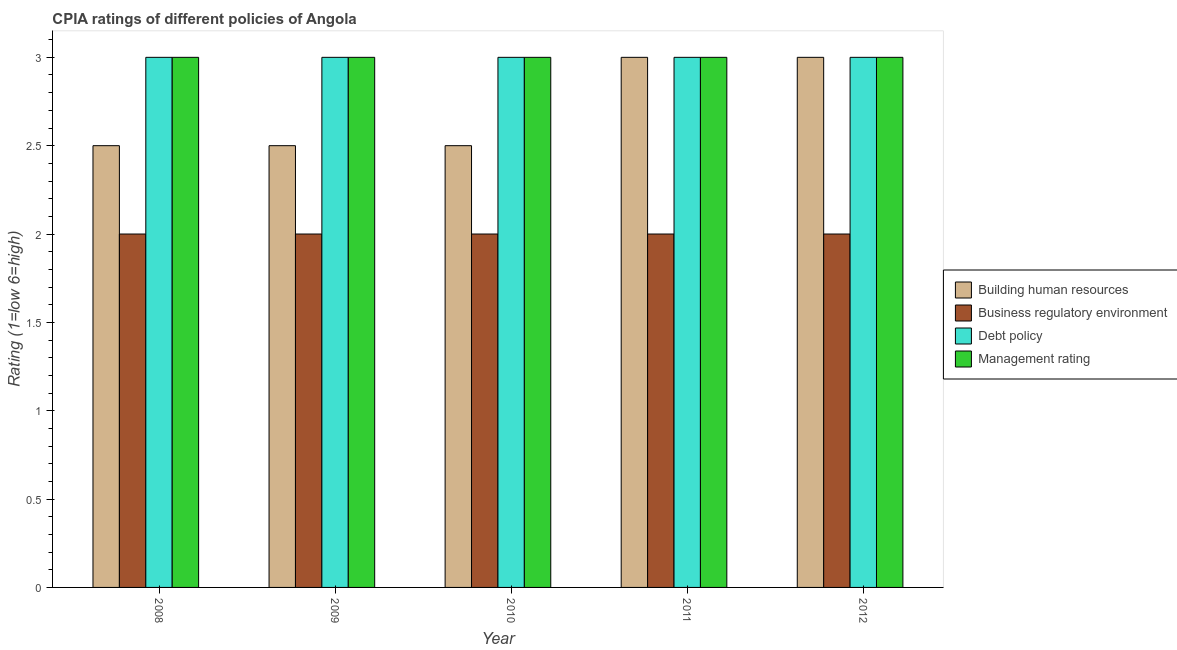How many bars are there on the 1st tick from the right?
Give a very brief answer. 4. What is the label of the 1st group of bars from the left?
Ensure brevity in your answer.  2008. In how many cases, is the number of bars for a given year not equal to the number of legend labels?
Provide a succinct answer. 0. Across all years, what is the maximum cpia rating of business regulatory environment?
Keep it short and to the point. 2. Across all years, what is the minimum cpia rating of debt policy?
Offer a terse response. 3. In which year was the cpia rating of management maximum?
Ensure brevity in your answer.  2008. In how many years, is the cpia rating of business regulatory environment greater than 0.30000000000000004?
Your answer should be very brief. 5. Is the difference between the cpia rating of management in 2008 and 2009 greater than the difference between the cpia rating of debt policy in 2008 and 2009?
Keep it short and to the point. No. What is the difference between the highest and the lowest cpia rating of debt policy?
Give a very brief answer. 0. Is it the case that in every year, the sum of the cpia rating of building human resources and cpia rating of debt policy is greater than the sum of cpia rating of management and cpia rating of business regulatory environment?
Give a very brief answer. No. What does the 3rd bar from the left in 2011 represents?
Your response must be concise. Debt policy. What does the 4th bar from the right in 2012 represents?
Offer a very short reply. Building human resources. Is it the case that in every year, the sum of the cpia rating of building human resources and cpia rating of business regulatory environment is greater than the cpia rating of debt policy?
Ensure brevity in your answer.  Yes. How many bars are there?
Your answer should be very brief. 20. Are all the bars in the graph horizontal?
Your answer should be very brief. No. What is the difference between two consecutive major ticks on the Y-axis?
Ensure brevity in your answer.  0.5. Are the values on the major ticks of Y-axis written in scientific E-notation?
Provide a short and direct response. No. Where does the legend appear in the graph?
Your response must be concise. Center right. How many legend labels are there?
Give a very brief answer. 4. What is the title of the graph?
Your answer should be compact. CPIA ratings of different policies of Angola. Does "Custom duties" appear as one of the legend labels in the graph?
Your answer should be compact. No. What is the label or title of the Y-axis?
Provide a short and direct response. Rating (1=low 6=high). What is the Rating (1=low 6=high) in Building human resources in 2008?
Offer a terse response. 2.5. What is the Rating (1=low 6=high) in Debt policy in 2008?
Offer a terse response. 3. What is the Rating (1=low 6=high) of Management rating in 2008?
Your answer should be compact. 3. What is the Rating (1=low 6=high) of Business regulatory environment in 2009?
Keep it short and to the point. 2. What is the Rating (1=low 6=high) in Management rating in 2009?
Offer a terse response. 3. What is the Rating (1=low 6=high) of Building human resources in 2010?
Your answer should be compact. 2.5. What is the Rating (1=low 6=high) in Debt policy in 2010?
Offer a very short reply. 3. What is the Rating (1=low 6=high) in Management rating in 2010?
Provide a succinct answer. 3. What is the Rating (1=low 6=high) of Management rating in 2011?
Your answer should be compact. 3. What is the Rating (1=low 6=high) in Building human resources in 2012?
Make the answer very short. 3. What is the Rating (1=low 6=high) in Management rating in 2012?
Ensure brevity in your answer.  3. Across all years, what is the maximum Rating (1=low 6=high) of Debt policy?
Provide a short and direct response. 3. Across all years, what is the maximum Rating (1=low 6=high) in Management rating?
Offer a terse response. 3. Across all years, what is the minimum Rating (1=low 6=high) of Debt policy?
Provide a short and direct response. 3. What is the difference between the Rating (1=low 6=high) of Business regulatory environment in 2008 and that in 2009?
Provide a succinct answer. 0. What is the difference between the Rating (1=low 6=high) in Management rating in 2008 and that in 2009?
Offer a terse response. 0. What is the difference between the Rating (1=low 6=high) of Building human resources in 2008 and that in 2010?
Provide a short and direct response. 0. What is the difference between the Rating (1=low 6=high) of Business regulatory environment in 2008 and that in 2010?
Provide a succinct answer. 0. What is the difference between the Rating (1=low 6=high) in Debt policy in 2008 and that in 2010?
Your answer should be very brief. 0. What is the difference between the Rating (1=low 6=high) of Debt policy in 2008 and that in 2011?
Keep it short and to the point. 0. What is the difference between the Rating (1=low 6=high) of Management rating in 2008 and that in 2011?
Provide a succinct answer. 0. What is the difference between the Rating (1=low 6=high) of Business regulatory environment in 2008 and that in 2012?
Provide a succinct answer. 0. What is the difference between the Rating (1=low 6=high) of Management rating in 2008 and that in 2012?
Your response must be concise. 0. What is the difference between the Rating (1=low 6=high) of Business regulatory environment in 2009 and that in 2010?
Ensure brevity in your answer.  0. What is the difference between the Rating (1=low 6=high) of Debt policy in 2009 and that in 2010?
Offer a terse response. 0. What is the difference between the Rating (1=low 6=high) of Business regulatory environment in 2009 and that in 2011?
Provide a succinct answer. 0. What is the difference between the Rating (1=low 6=high) of Debt policy in 2009 and that in 2011?
Offer a very short reply. 0. What is the difference between the Rating (1=low 6=high) in Debt policy in 2009 and that in 2012?
Make the answer very short. 0. What is the difference between the Rating (1=low 6=high) in Management rating in 2009 and that in 2012?
Your answer should be very brief. 0. What is the difference between the Rating (1=low 6=high) in Building human resources in 2010 and that in 2011?
Ensure brevity in your answer.  -0.5. What is the difference between the Rating (1=low 6=high) of Debt policy in 2010 and that in 2011?
Provide a short and direct response. 0. What is the difference between the Rating (1=low 6=high) in Debt policy in 2010 and that in 2012?
Offer a very short reply. 0. What is the difference between the Rating (1=low 6=high) of Management rating in 2010 and that in 2012?
Give a very brief answer. 0. What is the difference between the Rating (1=low 6=high) of Building human resources in 2011 and that in 2012?
Make the answer very short. 0. What is the difference between the Rating (1=low 6=high) in Debt policy in 2011 and that in 2012?
Provide a short and direct response. 0. What is the difference between the Rating (1=low 6=high) of Management rating in 2011 and that in 2012?
Your answer should be very brief. 0. What is the difference between the Rating (1=low 6=high) in Building human resources in 2008 and the Rating (1=low 6=high) in Business regulatory environment in 2009?
Offer a terse response. 0.5. What is the difference between the Rating (1=low 6=high) in Building human resources in 2008 and the Rating (1=low 6=high) in Debt policy in 2009?
Ensure brevity in your answer.  -0.5. What is the difference between the Rating (1=low 6=high) of Building human resources in 2008 and the Rating (1=low 6=high) of Business regulatory environment in 2010?
Provide a succinct answer. 0.5. What is the difference between the Rating (1=low 6=high) of Building human resources in 2008 and the Rating (1=low 6=high) of Debt policy in 2010?
Your response must be concise. -0.5. What is the difference between the Rating (1=low 6=high) in Business regulatory environment in 2008 and the Rating (1=low 6=high) in Debt policy in 2010?
Give a very brief answer. -1. What is the difference between the Rating (1=low 6=high) of Business regulatory environment in 2008 and the Rating (1=low 6=high) of Management rating in 2010?
Your response must be concise. -1. What is the difference between the Rating (1=low 6=high) in Debt policy in 2008 and the Rating (1=low 6=high) in Management rating in 2010?
Offer a terse response. 0. What is the difference between the Rating (1=low 6=high) in Building human resources in 2008 and the Rating (1=low 6=high) in Debt policy in 2011?
Your response must be concise. -0.5. What is the difference between the Rating (1=low 6=high) of Building human resources in 2008 and the Rating (1=low 6=high) of Management rating in 2011?
Your answer should be compact. -0.5. What is the difference between the Rating (1=low 6=high) of Business regulatory environment in 2008 and the Rating (1=low 6=high) of Debt policy in 2011?
Keep it short and to the point. -1. What is the difference between the Rating (1=low 6=high) in Building human resources in 2008 and the Rating (1=low 6=high) in Management rating in 2012?
Offer a terse response. -0.5. What is the difference between the Rating (1=low 6=high) of Business regulatory environment in 2008 and the Rating (1=low 6=high) of Debt policy in 2012?
Your answer should be very brief. -1. What is the difference between the Rating (1=low 6=high) of Debt policy in 2008 and the Rating (1=low 6=high) of Management rating in 2012?
Your answer should be very brief. 0. What is the difference between the Rating (1=low 6=high) of Building human resources in 2009 and the Rating (1=low 6=high) of Debt policy in 2010?
Provide a short and direct response. -0.5. What is the difference between the Rating (1=low 6=high) in Building human resources in 2009 and the Rating (1=low 6=high) in Management rating in 2010?
Provide a short and direct response. -0.5. What is the difference between the Rating (1=low 6=high) in Debt policy in 2009 and the Rating (1=low 6=high) in Management rating in 2010?
Your response must be concise. 0. What is the difference between the Rating (1=low 6=high) of Building human resources in 2009 and the Rating (1=low 6=high) of Debt policy in 2011?
Your answer should be very brief. -0.5. What is the difference between the Rating (1=low 6=high) in Debt policy in 2009 and the Rating (1=low 6=high) in Management rating in 2011?
Provide a succinct answer. 0. What is the difference between the Rating (1=low 6=high) of Building human resources in 2009 and the Rating (1=low 6=high) of Management rating in 2012?
Your response must be concise. -0.5. What is the difference between the Rating (1=low 6=high) of Business regulatory environment in 2010 and the Rating (1=low 6=high) of Debt policy in 2011?
Give a very brief answer. -1. What is the difference between the Rating (1=low 6=high) in Debt policy in 2010 and the Rating (1=low 6=high) in Management rating in 2011?
Ensure brevity in your answer.  0. What is the difference between the Rating (1=low 6=high) of Business regulatory environment in 2010 and the Rating (1=low 6=high) of Management rating in 2012?
Make the answer very short. -1. What is the difference between the Rating (1=low 6=high) of Building human resources in 2011 and the Rating (1=low 6=high) of Business regulatory environment in 2012?
Offer a terse response. 1. What is the difference between the Rating (1=low 6=high) of Building human resources in 2011 and the Rating (1=low 6=high) of Debt policy in 2012?
Offer a very short reply. 0. What is the difference between the Rating (1=low 6=high) in Debt policy in 2011 and the Rating (1=low 6=high) in Management rating in 2012?
Your response must be concise. 0. What is the average Rating (1=low 6=high) of Debt policy per year?
Keep it short and to the point. 3. What is the average Rating (1=low 6=high) of Management rating per year?
Provide a short and direct response. 3. In the year 2008, what is the difference between the Rating (1=low 6=high) of Building human resources and Rating (1=low 6=high) of Business regulatory environment?
Make the answer very short. 0.5. In the year 2008, what is the difference between the Rating (1=low 6=high) of Building human resources and Rating (1=low 6=high) of Management rating?
Your response must be concise. -0.5. In the year 2008, what is the difference between the Rating (1=low 6=high) in Business regulatory environment and Rating (1=low 6=high) in Debt policy?
Your answer should be compact. -1. In the year 2008, what is the difference between the Rating (1=low 6=high) in Business regulatory environment and Rating (1=low 6=high) in Management rating?
Your answer should be very brief. -1. In the year 2009, what is the difference between the Rating (1=low 6=high) of Building human resources and Rating (1=low 6=high) of Debt policy?
Your response must be concise. -0.5. In the year 2009, what is the difference between the Rating (1=low 6=high) in Building human resources and Rating (1=low 6=high) in Management rating?
Your answer should be very brief. -0.5. In the year 2009, what is the difference between the Rating (1=low 6=high) of Business regulatory environment and Rating (1=low 6=high) of Debt policy?
Ensure brevity in your answer.  -1. In the year 2010, what is the difference between the Rating (1=low 6=high) of Building human resources and Rating (1=low 6=high) of Management rating?
Keep it short and to the point. -0.5. In the year 2010, what is the difference between the Rating (1=low 6=high) in Debt policy and Rating (1=low 6=high) in Management rating?
Ensure brevity in your answer.  0. In the year 2011, what is the difference between the Rating (1=low 6=high) of Building human resources and Rating (1=low 6=high) of Debt policy?
Your answer should be compact. 0. In the year 2011, what is the difference between the Rating (1=low 6=high) in Building human resources and Rating (1=low 6=high) in Management rating?
Ensure brevity in your answer.  0. In the year 2012, what is the difference between the Rating (1=low 6=high) in Business regulatory environment and Rating (1=low 6=high) in Management rating?
Make the answer very short. -1. In the year 2012, what is the difference between the Rating (1=low 6=high) in Debt policy and Rating (1=low 6=high) in Management rating?
Your answer should be compact. 0. What is the ratio of the Rating (1=low 6=high) of Building human resources in 2008 to that in 2009?
Your response must be concise. 1. What is the ratio of the Rating (1=low 6=high) in Business regulatory environment in 2008 to that in 2009?
Make the answer very short. 1. What is the ratio of the Rating (1=low 6=high) in Management rating in 2008 to that in 2009?
Your answer should be very brief. 1. What is the ratio of the Rating (1=low 6=high) of Building human resources in 2008 to that in 2010?
Provide a succinct answer. 1. What is the ratio of the Rating (1=low 6=high) in Management rating in 2008 to that in 2010?
Make the answer very short. 1. What is the ratio of the Rating (1=low 6=high) in Building human resources in 2008 to that in 2011?
Make the answer very short. 0.83. What is the ratio of the Rating (1=low 6=high) of Business regulatory environment in 2008 to that in 2011?
Keep it short and to the point. 1. What is the ratio of the Rating (1=low 6=high) of Debt policy in 2008 to that in 2011?
Provide a short and direct response. 1. What is the ratio of the Rating (1=low 6=high) in Building human resources in 2008 to that in 2012?
Provide a succinct answer. 0.83. What is the ratio of the Rating (1=low 6=high) in Debt policy in 2008 to that in 2012?
Provide a succinct answer. 1. What is the ratio of the Rating (1=low 6=high) in Management rating in 2008 to that in 2012?
Your response must be concise. 1. What is the ratio of the Rating (1=low 6=high) of Building human resources in 2009 to that in 2010?
Offer a very short reply. 1. What is the ratio of the Rating (1=low 6=high) in Building human resources in 2009 to that in 2011?
Provide a short and direct response. 0.83. What is the ratio of the Rating (1=low 6=high) of Business regulatory environment in 2009 to that in 2011?
Your response must be concise. 1. What is the ratio of the Rating (1=low 6=high) of Building human resources in 2009 to that in 2012?
Provide a succinct answer. 0.83. What is the ratio of the Rating (1=low 6=high) of Business regulatory environment in 2010 to that in 2011?
Give a very brief answer. 1. What is the ratio of the Rating (1=low 6=high) of Business regulatory environment in 2010 to that in 2012?
Make the answer very short. 1. What is the ratio of the Rating (1=low 6=high) of Building human resources in 2011 to that in 2012?
Offer a very short reply. 1. What is the ratio of the Rating (1=low 6=high) in Debt policy in 2011 to that in 2012?
Provide a short and direct response. 1. What is the ratio of the Rating (1=low 6=high) in Management rating in 2011 to that in 2012?
Give a very brief answer. 1. What is the difference between the highest and the second highest Rating (1=low 6=high) of Building human resources?
Provide a succinct answer. 0. What is the difference between the highest and the second highest Rating (1=low 6=high) in Debt policy?
Make the answer very short. 0. What is the difference between the highest and the second highest Rating (1=low 6=high) in Management rating?
Your answer should be very brief. 0. What is the difference between the highest and the lowest Rating (1=low 6=high) in Debt policy?
Your answer should be very brief. 0. 